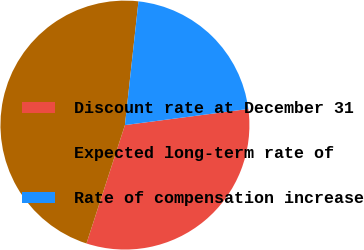Convert chart. <chart><loc_0><loc_0><loc_500><loc_500><pie_chart><fcel>Discount rate at December 31<fcel>Expected long-term rate of<fcel>Rate of compensation increase<nl><fcel>32.07%<fcel>46.74%<fcel>21.2%<nl></chart> 